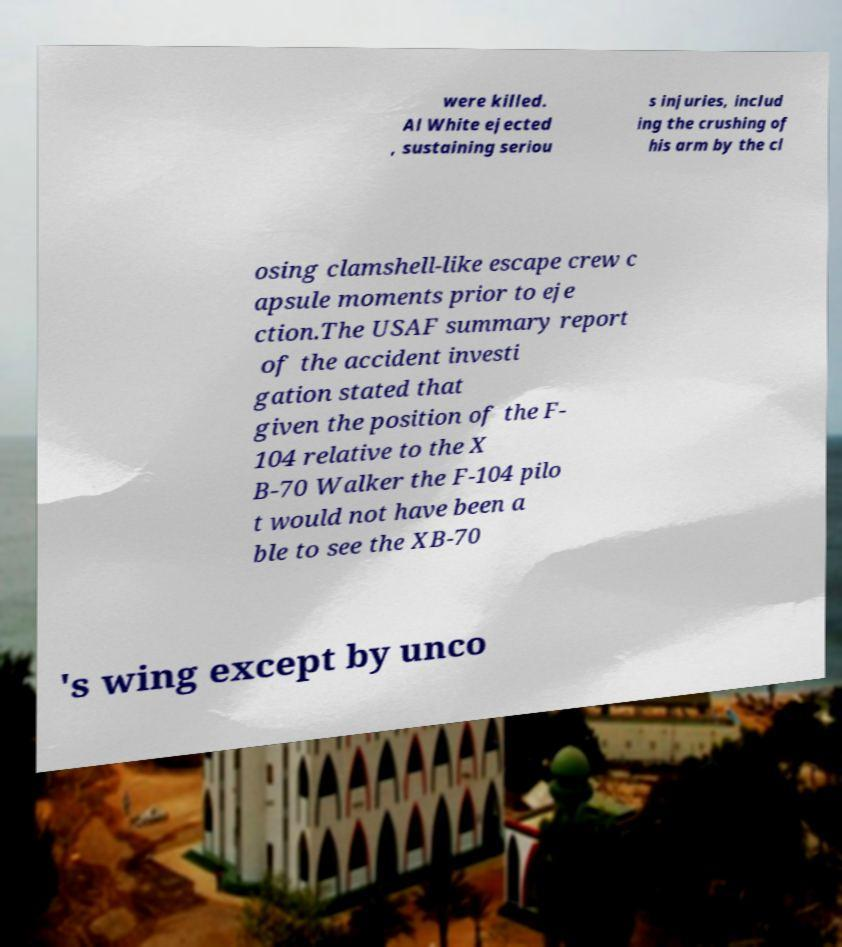Please identify and transcribe the text found in this image. were killed. Al White ejected , sustaining seriou s injuries, includ ing the crushing of his arm by the cl osing clamshell-like escape crew c apsule moments prior to eje ction.The USAF summary report of the accident investi gation stated that given the position of the F- 104 relative to the X B-70 Walker the F-104 pilo t would not have been a ble to see the XB-70 's wing except by unco 